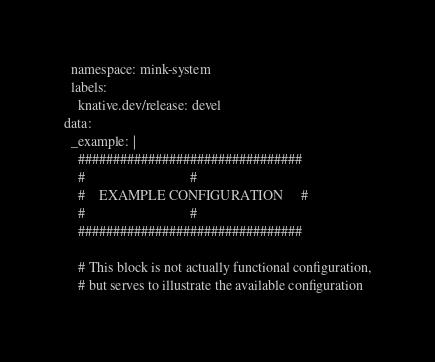<code> <loc_0><loc_0><loc_500><loc_500><_YAML_>  namespace: mink-system
  labels:
    knative.dev/release: devel
data:
  _example: |
    ################################
    #                              #
    #    EXAMPLE CONFIGURATION     #
    #                              #
    ################################

    # This block is not actually functional configuration,
    # but serves to illustrate the available configuration</code> 